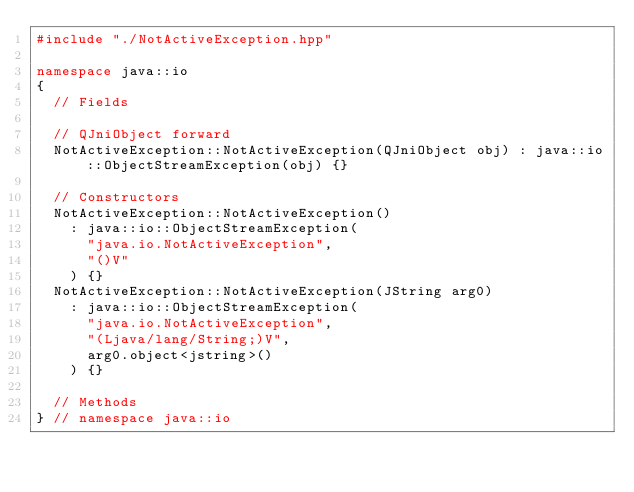Convert code to text. <code><loc_0><loc_0><loc_500><loc_500><_C++_>#include "./NotActiveException.hpp"

namespace java::io
{
	// Fields
	
	// QJniObject forward
	NotActiveException::NotActiveException(QJniObject obj) : java::io::ObjectStreamException(obj) {}
	
	// Constructors
	NotActiveException::NotActiveException()
		: java::io::ObjectStreamException(
			"java.io.NotActiveException",
			"()V"
		) {}
	NotActiveException::NotActiveException(JString arg0)
		: java::io::ObjectStreamException(
			"java.io.NotActiveException",
			"(Ljava/lang/String;)V",
			arg0.object<jstring>()
		) {}
	
	// Methods
} // namespace java::io

</code> 